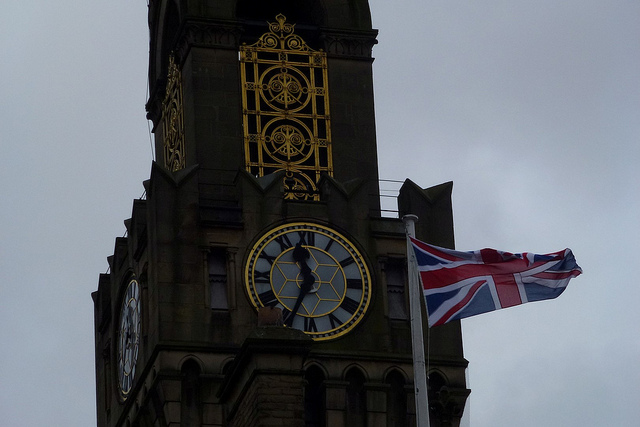What architectural style is the tower designed in? The tower is designed in a Victorian Gothic architectural style, characterized by its ornate detailing and pointed arches that are typical of the era. 